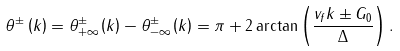<formula> <loc_0><loc_0><loc_500><loc_500>\theta ^ { \pm } \left ( k \right ) = \theta _ { + \infty } ^ { \pm } \left ( k \right ) - \theta _ { - \infty } ^ { \pm } \left ( k \right ) = \pi + 2 \arctan \left ( \frac { v _ { f } k \pm G _ { 0 } } { \Delta } \right ) .</formula> 